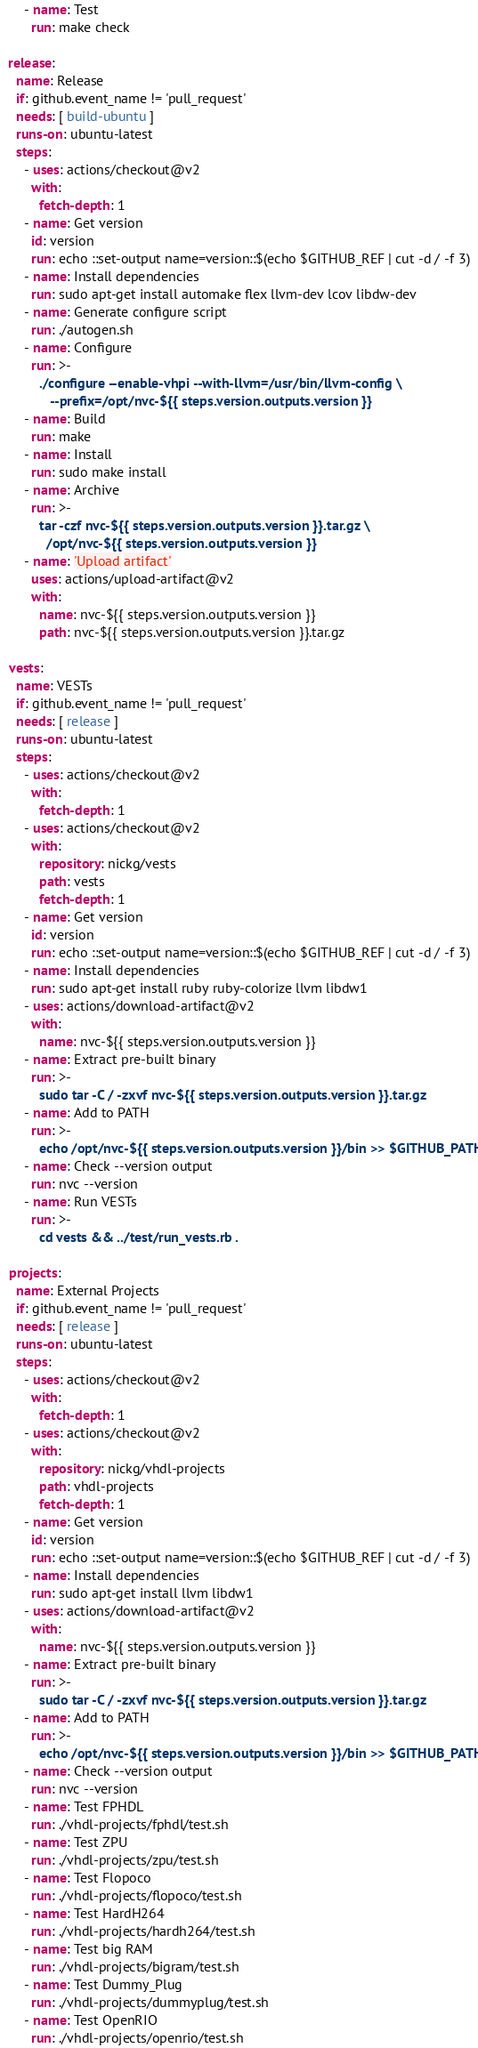<code> <loc_0><loc_0><loc_500><loc_500><_YAML_>      - name: Test
        run: make check

  release:
    name: Release
    if: github.event_name != 'pull_request'
    needs: [ build-ubuntu ]
    runs-on: ubuntu-latest
    steps:
      - uses: actions/checkout@v2
        with:
          fetch-depth: 1
      - name: Get version
        id: version
        run: echo ::set-output name=version::$(echo $GITHUB_REF | cut -d / -f 3)
      - name: Install dependencies
        run: sudo apt-get install automake flex llvm-dev lcov libdw-dev
      - name: Generate configure script
        run: ./autogen.sh
      - name: Configure
        run: >-
          ./configure --enable-vhpi --with-llvm=/usr/bin/llvm-config \
             --prefix=/opt/nvc-${{ steps.version.outputs.version }}
      - name: Build
        run: make
      - name: Install
        run: sudo make install
      - name: Archive
        run: >-
          tar -czf nvc-${{ steps.version.outputs.version }}.tar.gz \
            /opt/nvc-${{ steps.version.outputs.version }}
      - name: 'Upload artifact'
        uses: actions/upload-artifact@v2
        with:
          name: nvc-${{ steps.version.outputs.version }}
          path: nvc-${{ steps.version.outputs.version }}.tar.gz

  vests:
    name: VESTs
    if: github.event_name != 'pull_request'
    needs: [ release ]
    runs-on: ubuntu-latest
    steps:
      - uses: actions/checkout@v2
        with:
          fetch-depth: 1
      - uses: actions/checkout@v2
        with:
          repository: nickg/vests
          path: vests
          fetch-depth: 1
      - name: Get version
        id: version
        run: echo ::set-output name=version::$(echo $GITHUB_REF | cut -d / -f 3)
      - name: Install dependencies
        run: sudo apt-get install ruby ruby-colorize llvm libdw1
      - uses: actions/download-artifact@v2
        with:
          name: nvc-${{ steps.version.outputs.version }}
      - name: Extract pre-built binary
        run: >-
          sudo tar -C / -zxvf nvc-${{ steps.version.outputs.version }}.tar.gz
      - name: Add to PATH
        run: >-
          echo /opt/nvc-${{ steps.version.outputs.version }}/bin >> $GITHUB_PATH
      - name: Check --version output
        run: nvc --version
      - name: Run VESTs
        run: >-
          cd vests && ../test/run_vests.rb .

  projects:
    name: External Projects
    if: github.event_name != 'pull_request'
    needs: [ release ]
    runs-on: ubuntu-latest
    steps:
      - uses: actions/checkout@v2
        with:
          fetch-depth: 1
      - uses: actions/checkout@v2
        with:
          repository: nickg/vhdl-projects
          path: vhdl-projects
          fetch-depth: 1
      - name: Get version
        id: version
        run: echo ::set-output name=version::$(echo $GITHUB_REF | cut -d / -f 3)
      - name: Install dependencies
        run: sudo apt-get install llvm libdw1
      - uses: actions/download-artifact@v2
        with:
          name: nvc-${{ steps.version.outputs.version }}
      - name: Extract pre-built binary
        run: >-
          sudo tar -C / -zxvf nvc-${{ steps.version.outputs.version }}.tar.gz
      - name: Add to PATH
        run: >-
          echo /opt/nvc-${{ steps.version.outputs.version }}/bin >> $GITHUB_PATH
      - name: Check --version output
        run: nvc --version
      - name: Test FPHDL
        run: ./vhdl-projects/fphdl/test.sh
      - name: Test ZPU
        run: ./vhdl-projects/zpu/test.sh
      - name: Test Flopoco
        run: ./vhdl-projects/flopoco/test.sh
      - name: Test HardH264
        run: ./vhdl-projects/hardh264/test.sh
      - name: Test big RAM
        run: ./vhdl-projects/bigram/test.sh
      - name: Test Dummy_Plug
        run: ./vhdl-projects/dummyplug/test.sh
      - name: Test OpenRIO
        run: ./vhdl-projects/openrio/test.sh
</code> 